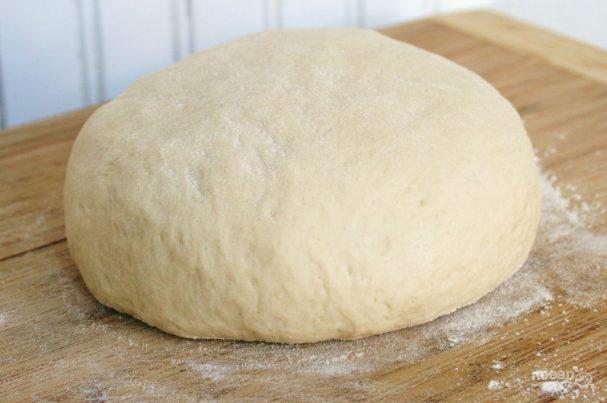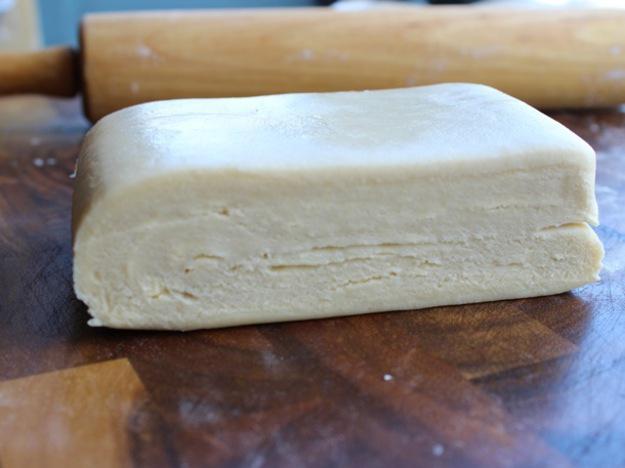The first image is the image on the left, the second image is the image on the right. For the images shown, is this caption "There is dough in plastic." true? Answer yes or no. No. The first image is the image on the left, the second image is the image on the right. Analyze the images presented: Is the assertion "There are two folded pieces of dough with one in plastic." valid? Answer yes or no. No. 